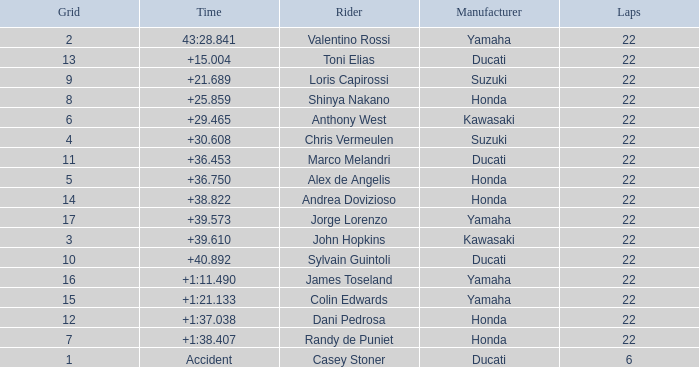On which laps did honda clock a time of +1:38.407? 22.0. 